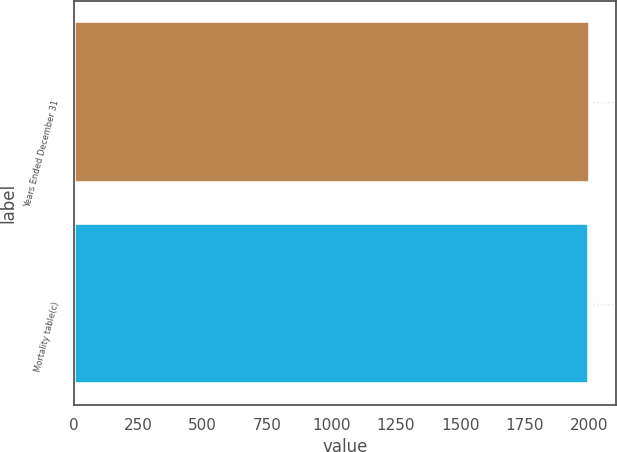Convert chart to OTSL. <chart><loc_0><loc_0><loc_500><loc_500><bar_chart><fcel>Years Ended December 31<fcel>Mortality table(c)<nl><fcel>2005<fcel>2000<nl></chart> 